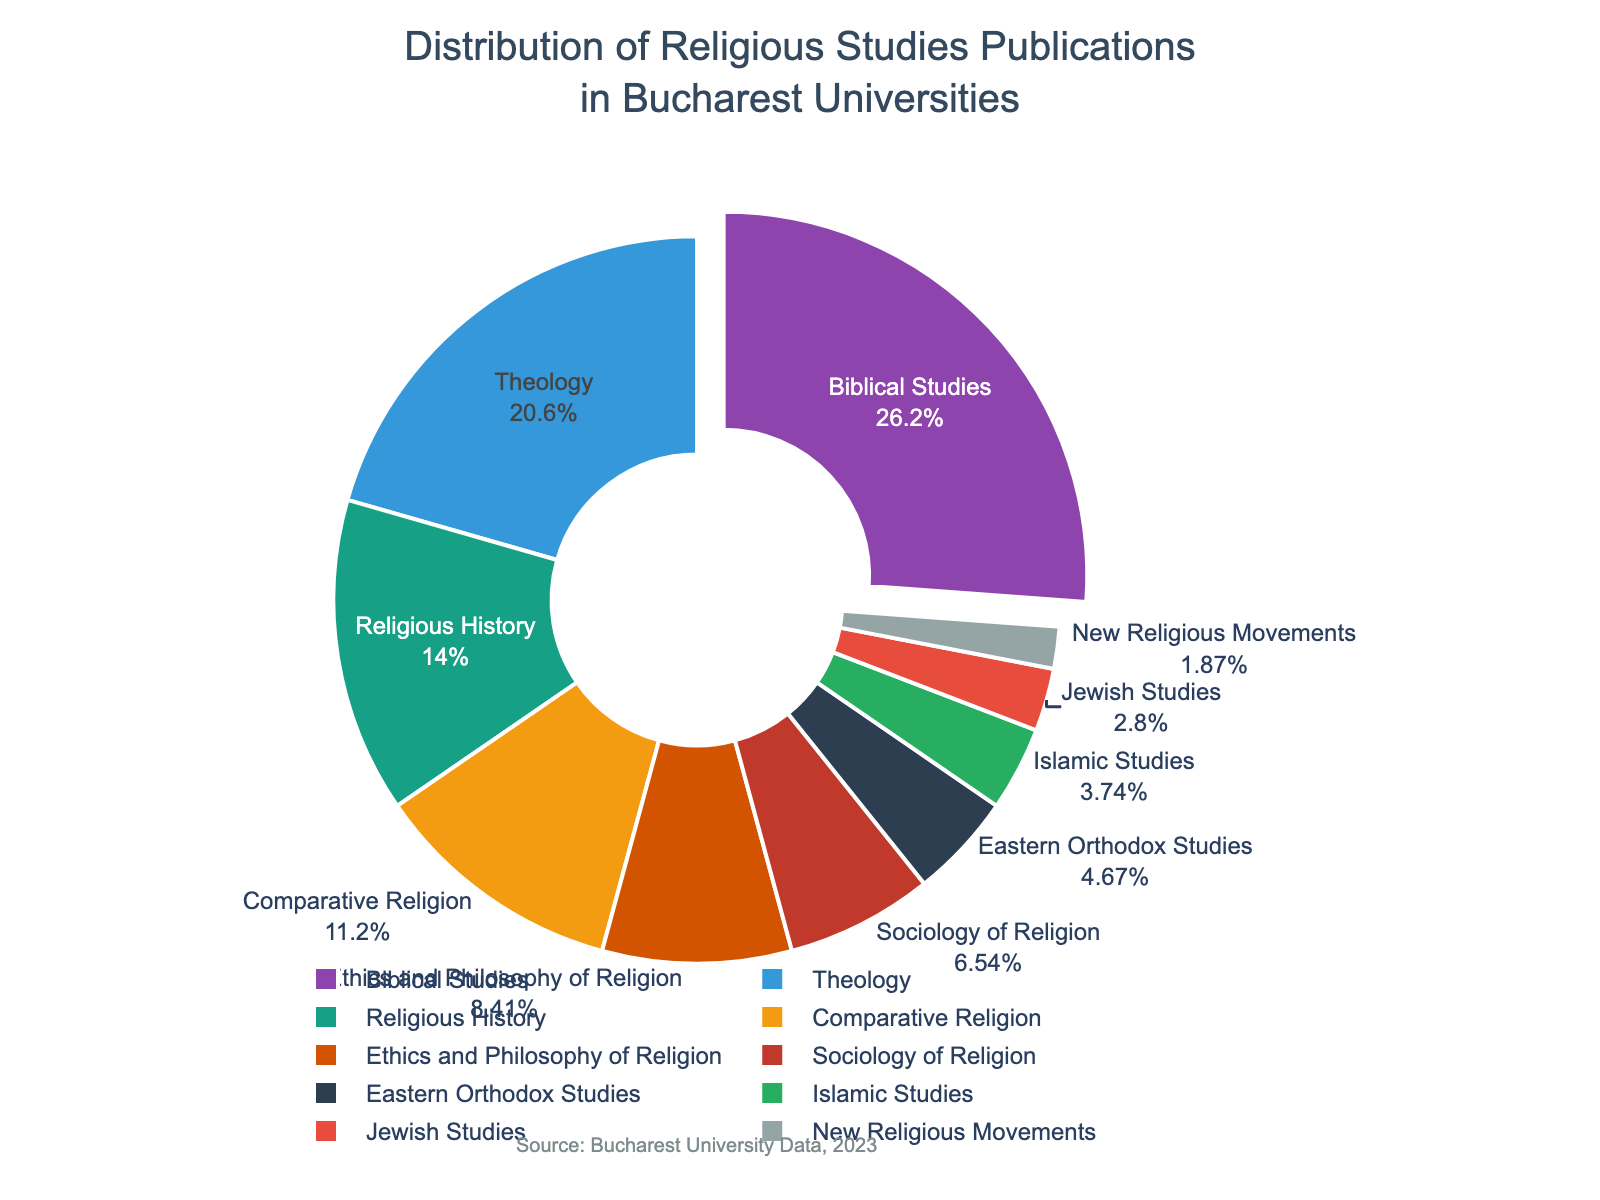Which subject area has the highest percentage of publications? Look at the pie chart and identify the segment with the highest label percentage. The segment labeled "Biblical Studies" has the largest percentage.
Answer: Biblical Studies What is the combined percentage of publications in Theology and Comparative Religion? Add the percentages for Theology (22%) and Comparative Religion (12%). The sum of these percentages is 22 + 12 = 34%.
Answer: 34% Which publication subject areas have a percentage less than 5%? Identify all segments in the pie chart with percentages below 5%, which are "Islamic Studies" (4%), "Jewish Studies" (3%), and "New Religious Movements" (2%).
Answer: Islamic Studies, Jewish Studies, New Religious Movements How much greater is the percentage of Biblical Studies publications compared to Sociology of Religion publications? Subtract the percentage of Sociology of Religion (7%) from the percentage of Biblical Studies (28%). The difference is 28 - 7 = 21%.
Answer: 21% What color represents the Ethics and Philosophy of Religion subject area in the pie chart? Review the color allocated to the segment labeled "Ethics and Philosophy of Religion", which appears in the orange hue.
Answer: Orange What is the difference in publication percentages between Religious History and Eastern Orthodox Studies? Subtract the percentage of Eastern Orthodox Studies (5%) from that of Religious History (15%). The difference is 15 - 5 = 10%.
Answer: 10% What percentage of publications fall under Biblical Studies? Check the segment labeled "Biblical Studies" in the pie chart. It represents 28% of the publications.
Answer: 28% Which subject has a higher percentage of publications: Ethics and Philosophy of Religion or Sociology of Religion? Compare the percentages directly. Ethics and Philosophy of Religion has 9%, while Sociology of Religion has 7%, so Ethics and Philosophy of Religion is higher.
Answer: Ethics and Philosophy of Religion What is the combined percentage of the three smallest publication subject areas? Sum the percentages of the three smallest areas, namely New Religious Movements (2%), Jewish Studies (3%), and Islamic Studies (4%). The total is 2 + 3 + 4 = 9%.
Answer: 9% If you combine the publications in Theology, Religious History, and Comparative Religion, what percentage of the total does that represent? Add the percentages of Theology (22%), Religious History (15%), and Comparative Religion (12%). The sum is 22 + 15 + 12 = 49%.
Answer: 49% 